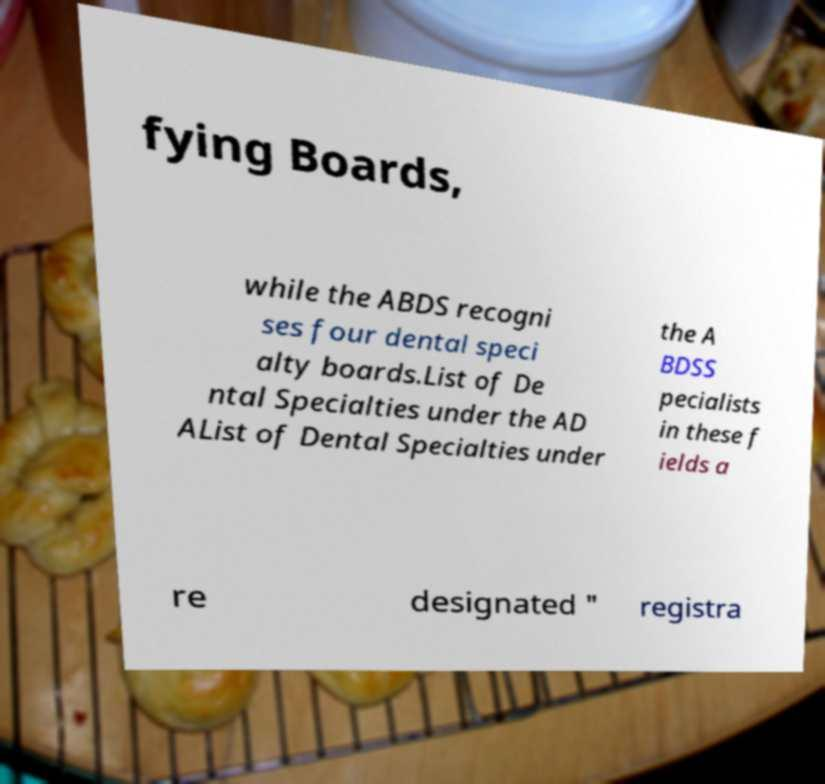Could you extract and type out the text from this image? fying Boards, while the ABDS recogni ses four dental speci alty boards.List of De ntal Specialties under the AD AList of Dental Specialties under the A BDSS pecialists in these f ields a re designated " registra 